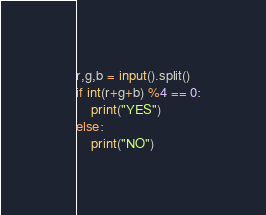<code> <loc_0><loc_0><loc_500><loc_500><_Python_>r,g,b = input().split()
if int(r+g+b) %4 == 0:
    print("YES")
else:
    print("NO")</code> 